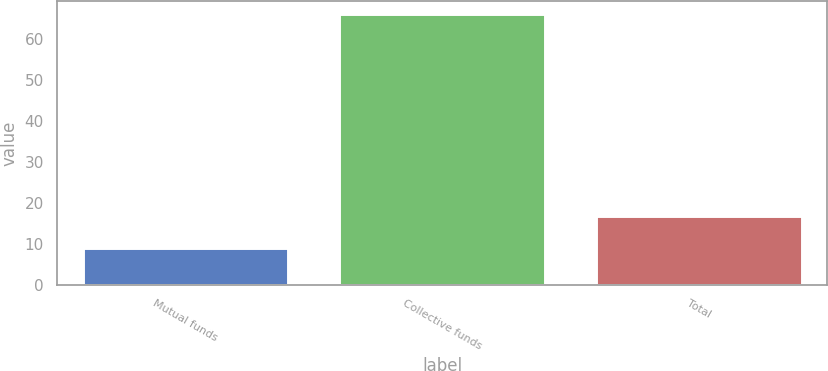<chart> <loc_0><loc_0><loc_500><loc_500><bar_chart><fcel>Mutual funds<fcel>Collective funds<fcel>Total<nl><fcel>9<fcel>66<fcel>17<nl></chart> 